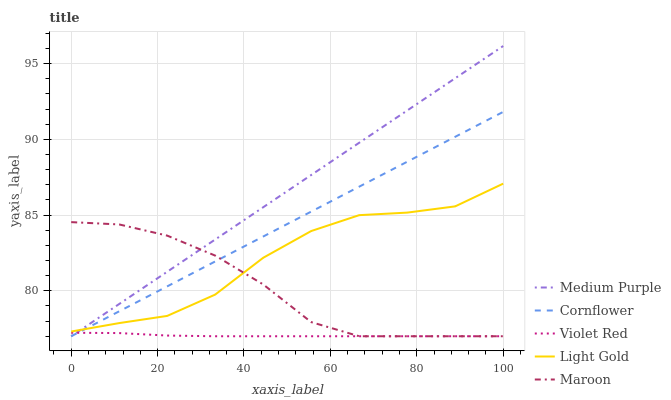Does Cornflower have the minimum area under the curve?
Answer yes or no. No. Does Cornflower have the maximum area under the curve?
Answer yes or no. No. Is Violet Red the smoothest?
Answer yes or no. No. Is Violet Red the roughest?
Answer yes or no. No. Does Light Gold have the lowest value?
Answer yes or no. No. Does Cornflower have the highest value?
Answer yes or no. No. Is Violet Red less than Light Gold?
Answer yes or no. Yes. Is Light Gold greater than Violet Red?
Answer yes or no. Yes. Does Violet Red intersect Light Gold?
Answer yes or no. No. 